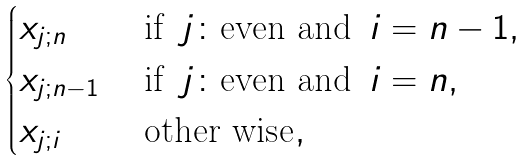<formula> <loc_0><loc_0><loc_500><loc_500>\begin{cases} x _ { j ; n } & \text { if } \, j \colon \text {even and } \, i = n - 1 , \\ x _ { j ; n - 1 } & \text { if } \, j \colon \text {even and } \, i = n , \\ x _ { j ; i } & \text { other wise} , \end{cases}</formula> 